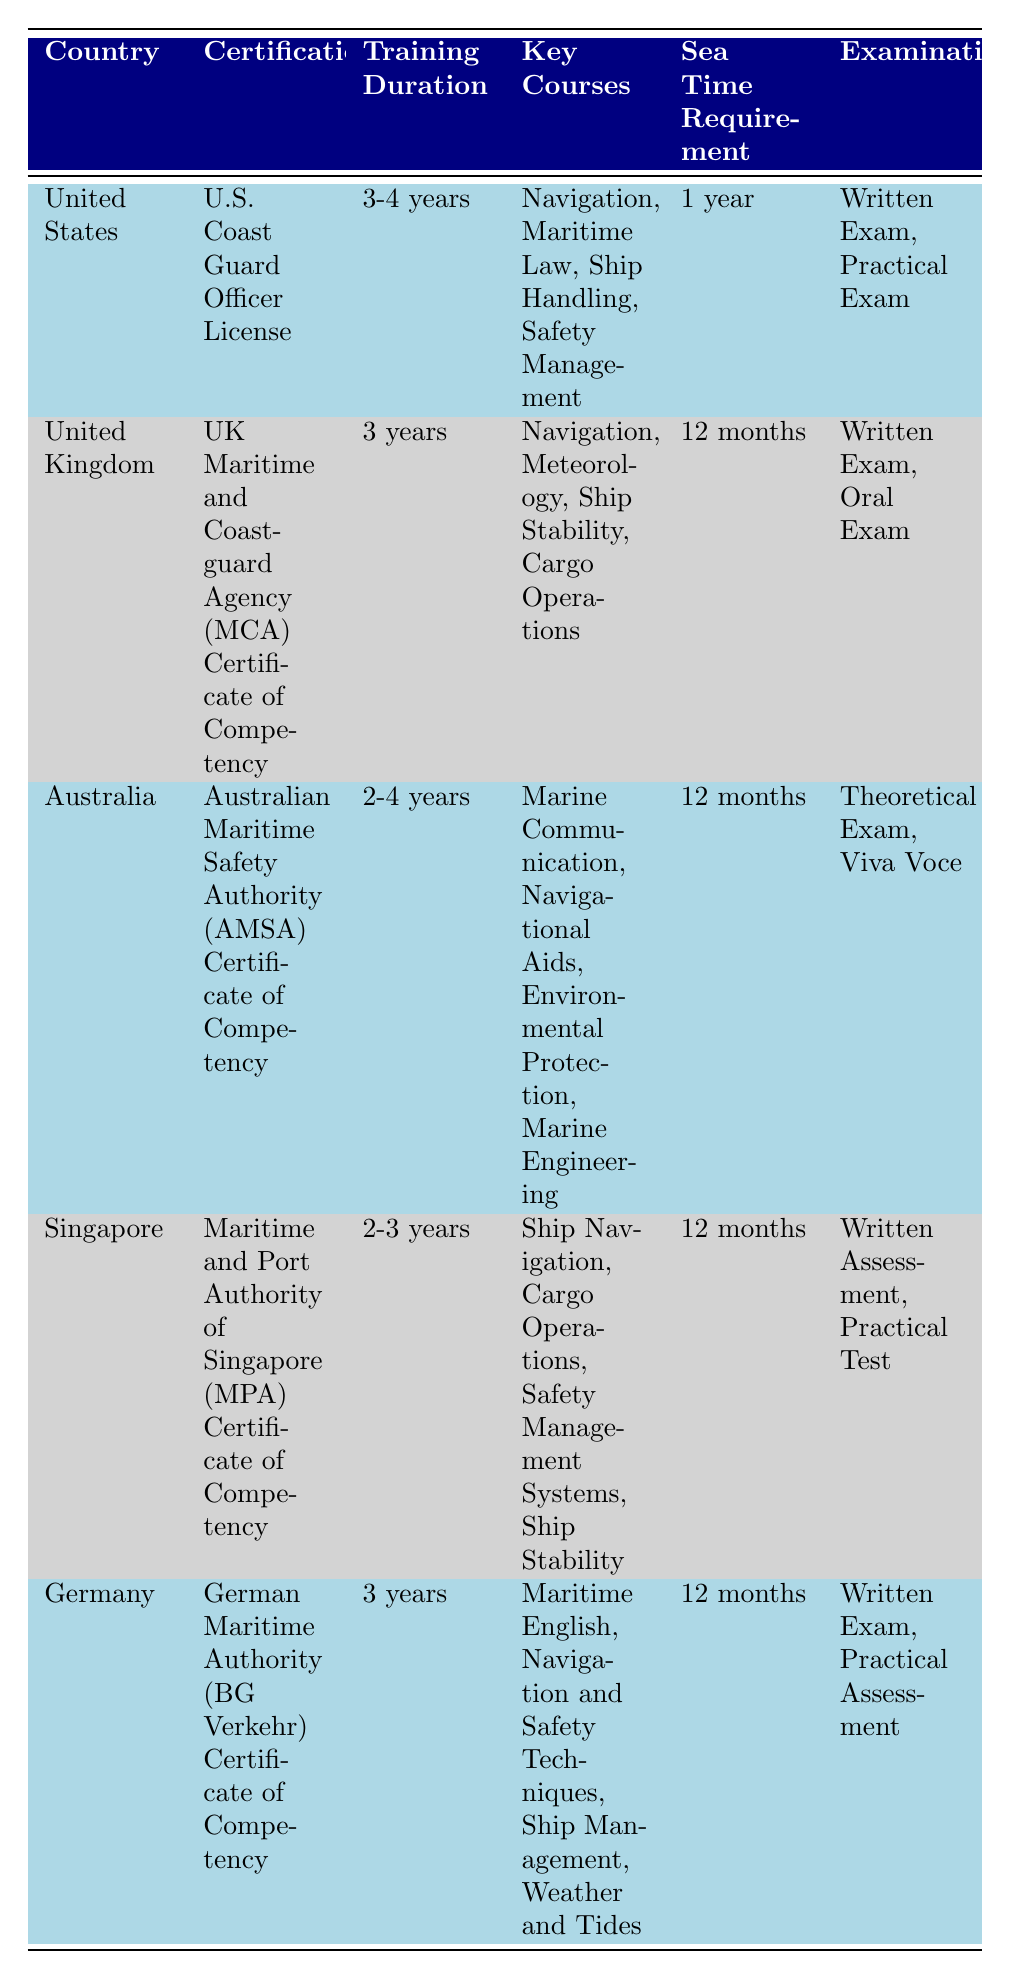What is the training duration for deck officers in the United Kingdom? According to the table, the training duration listed for the United Kingdom is 3 years.
Answer: 3 years What are the key courses for deck officer certification in Australia? The table specifies that the key courses in Australia include Marine Communication, Navigational Aids, Environmental Protection, and Marine Engineering.
Answer: Marine Communication, Navigational Aids, Environmental Protection, Marine Engineering How many countries require a sea time of 12 months for deck officers? By examining the table, we can see that the countries with a 12-month sea time requirement are the United Kingdom, Australia, Singapore, and Germany. This totals to 4 countries.
Answer: 4 Is the training duration for the certification in Singapore shorter than that in Australia? The training duration for Singapore is 2-3 years, while for Australia it is 2-4 years. Since 2-3 years is equal to or shorter than 2-4 years, it is true that Singapore has a shorter duration.
Answer: Yes What is the average training duration across the listed countries? The training durations for the countries are: United States (3.5 years average), United Kingdom (3 years), Australia (3 years average), Singapore (2.5 years average), Germany (3 years). To find the average, we calculate (3.5 + 3 + 3 + 2.5 + 3) / 5 = 3.2 years.
Answer: 3.2 years Which certification has the longest training duration in years? Reviewing the table, both the United States and Australia have a range of 3-4 years, which represents the longest durations. Since they have the same upper limit, we conclude that they are the longest.
Answer: United States and Australia Are there any examinations that are common among all the countries listed? By checking the examination types for each country, we can see that while some share written exams, there are no examinations that are common to all listed countries. Thus, the answer is no.
Answer: No What is the only certification that requires a practical test in examinations? In the provided data, the certification from Singapore has a Practical Test as one of its examinations, making it unique in this aspect compared to the others.
Answer: Maritime and Port Authority of Singapore (MPA) Certificate of Competency 